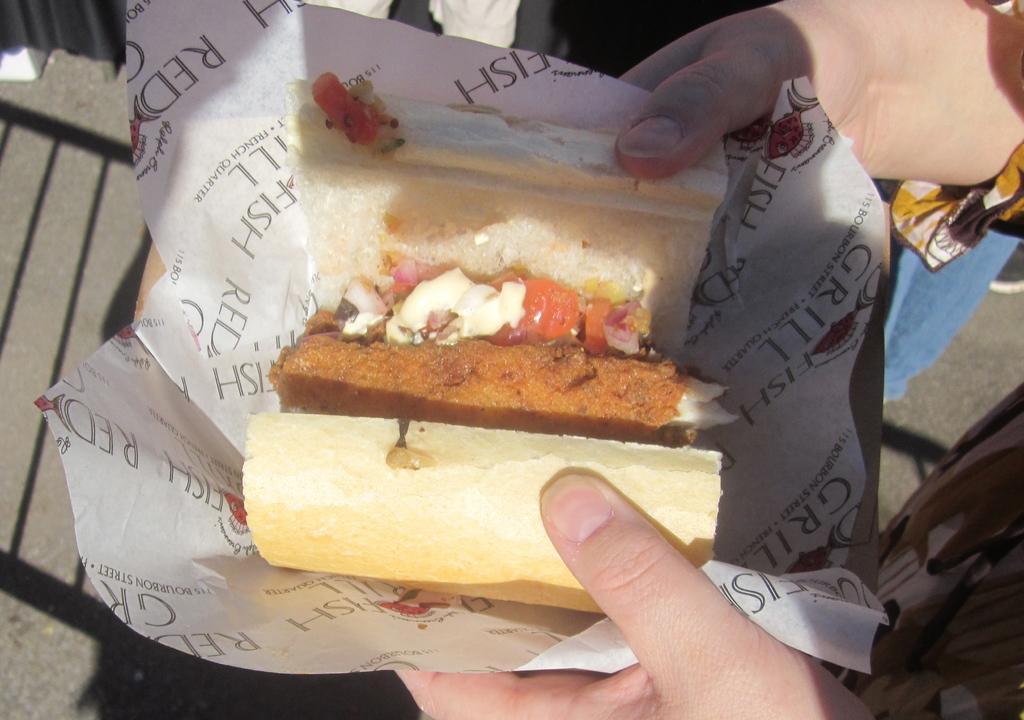Please provide a concise description of this image. In this image we can see a person holding a paper, in the paper, we can see some food and also we can see the person's legs and a black color curtain. 